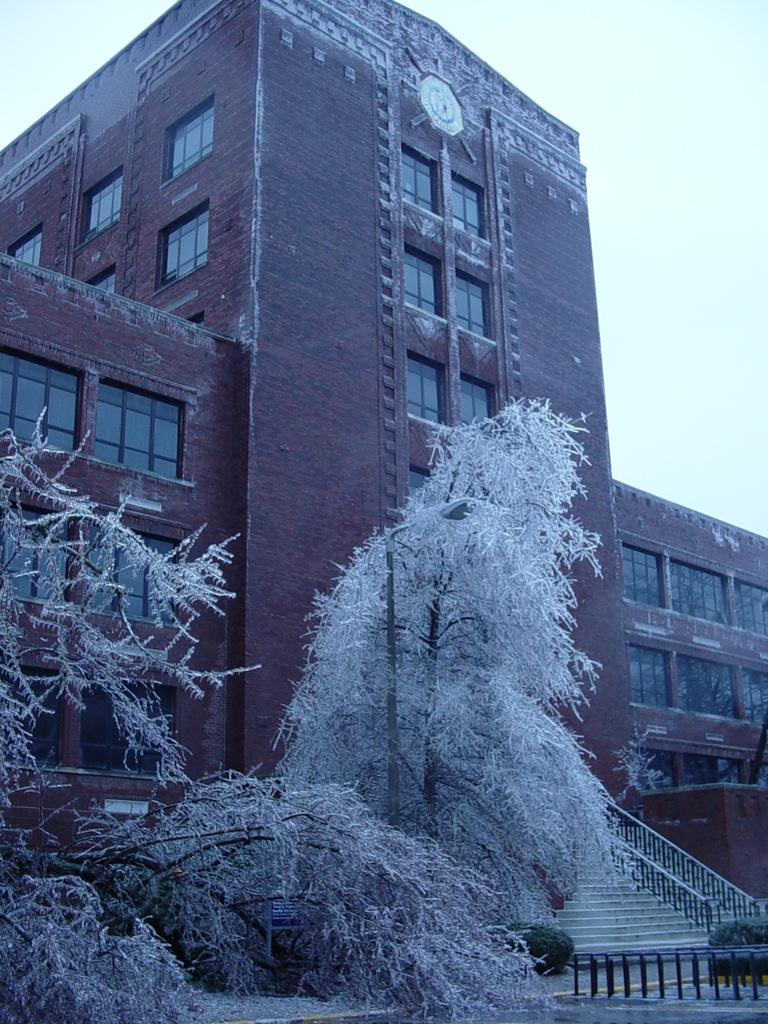What type of natural elements can be seen in the image? There are trees and plants in the image. What architectural features are present in the image? There are fences, steps, windows, and a building in the image. What is visible in the background of the image? The sky is visible in the background of the image. What type of trouble can be seen in the image? There is no trouble present in the image; it features trees, plants, fences, steps, windows, a building, and the sky. What scent is emanating from the pan in the image? There is no pan present in the image, so it is not possible to determine any associated scent. 